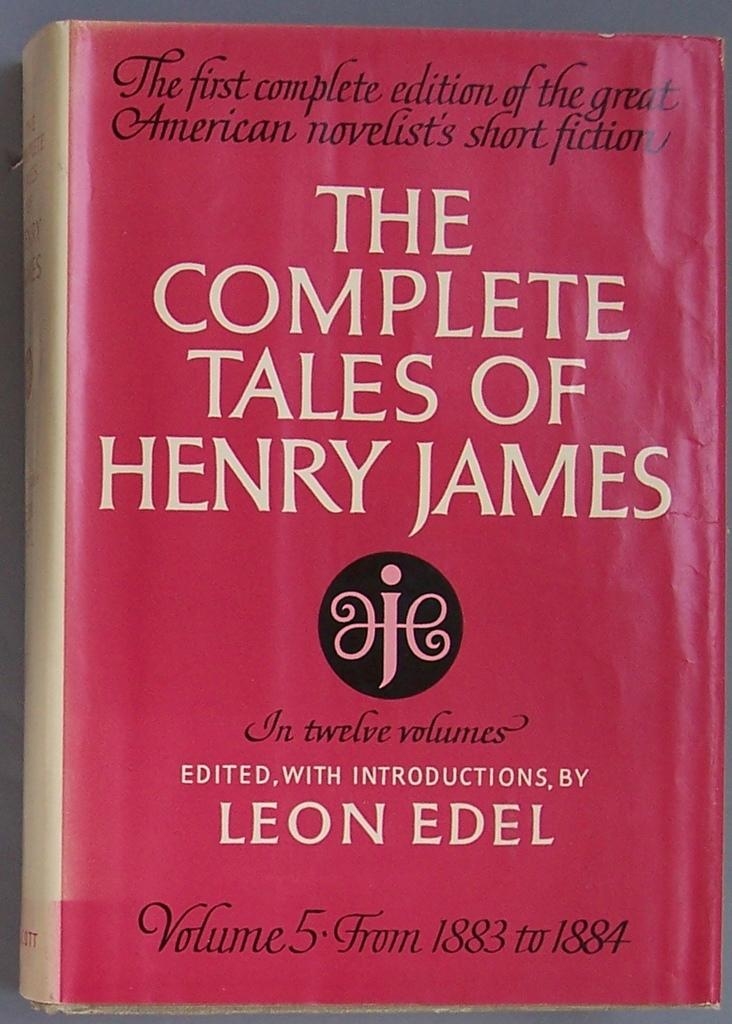<image>
Offer a succinct explanation of the picture presented. The book shown is the first complete edition. 